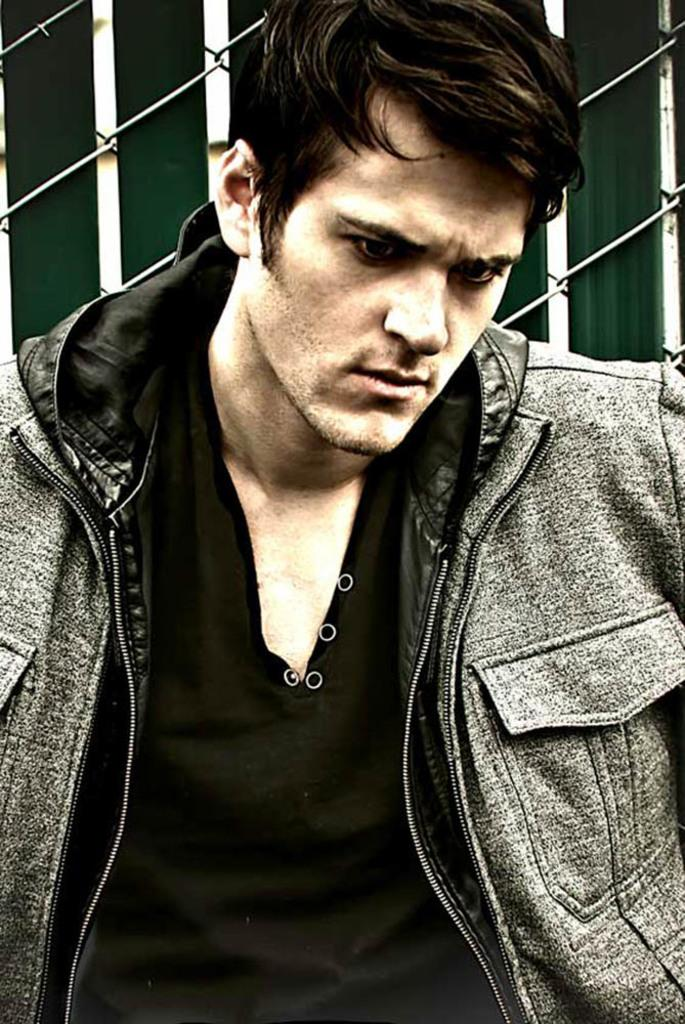Who is present in the image? There is a man in the image. What can be seen in the background of the image? There are iron wires in the background of the image. How many feathers can be seen floating in the image? There are no feathers present in the image. What type of clouds can be seen in the image? There are no clouds visible in the image; it only features a man and iron wires in the background. 